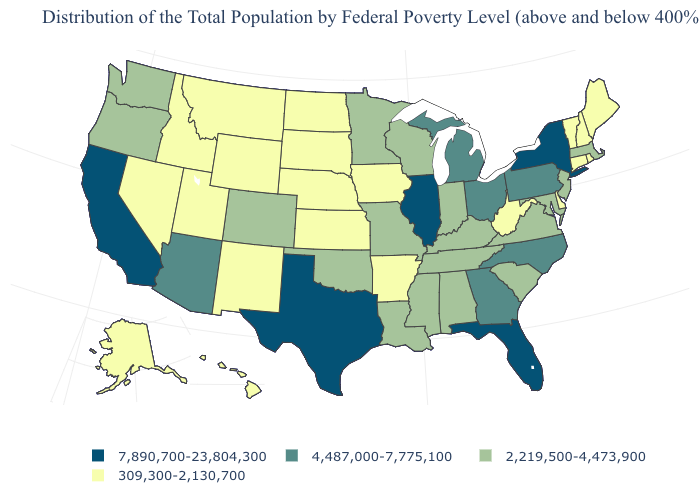What is the value of Pennsylvania?
Quick response, please. 4,487,000-7,775,100. Does the first symbol in the legend represent the smallest category?
Quick response, please. No. What is the highest value in the South ?
Give a very brief answer. 7,890,700-23,804,300. Which states have the highest value in the USA?
Answer briefly. California, Florida, Illinois, New York, Texas. Name the states that have a value in the range 7,890,700-23,804,300?
Keep it brief. California, Florida, Illinois, New York, Texas. What is the value of Oklahoma?
Write a very short answer. 2,219,500-4,473,900. What is the value of North Carolina?
Quick response, please. 4,487,000-7,775,100. Which states have the lowest value in the MidWest?
Concise answer only. Iowa, Kansas, Nebraska, North Dakota, South Dakota. What is the lowest value in the USA?
Write a very short answer. 309,300-2,130,700. What is the value of New Mexico?
Quick response, please. 309,300-2,130,700. Which states have the highest value in the USA?
Concise answer only. California, Florida, Illinois, New York, Texas. Does the map have missing data?
Answer briefly. No. Which states have the highest value in the USA?
Write a very short answer. California, Florida, Illinois, New York, Texas. Does Illinois have the highest value in the MidWest?
Be succinct. Yes. 